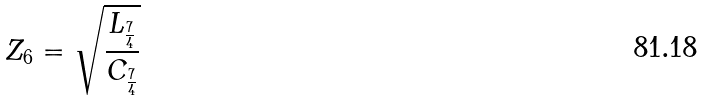Convert formula to latex. <formula><loc_0><loc_0><loc_500><loc_500>Z _ { 6 } = \sqrt { \frac { L _ { \frac { 7 } { 4 } } } { C _ { \frac { 7 } { 4 } } } }</formula> 